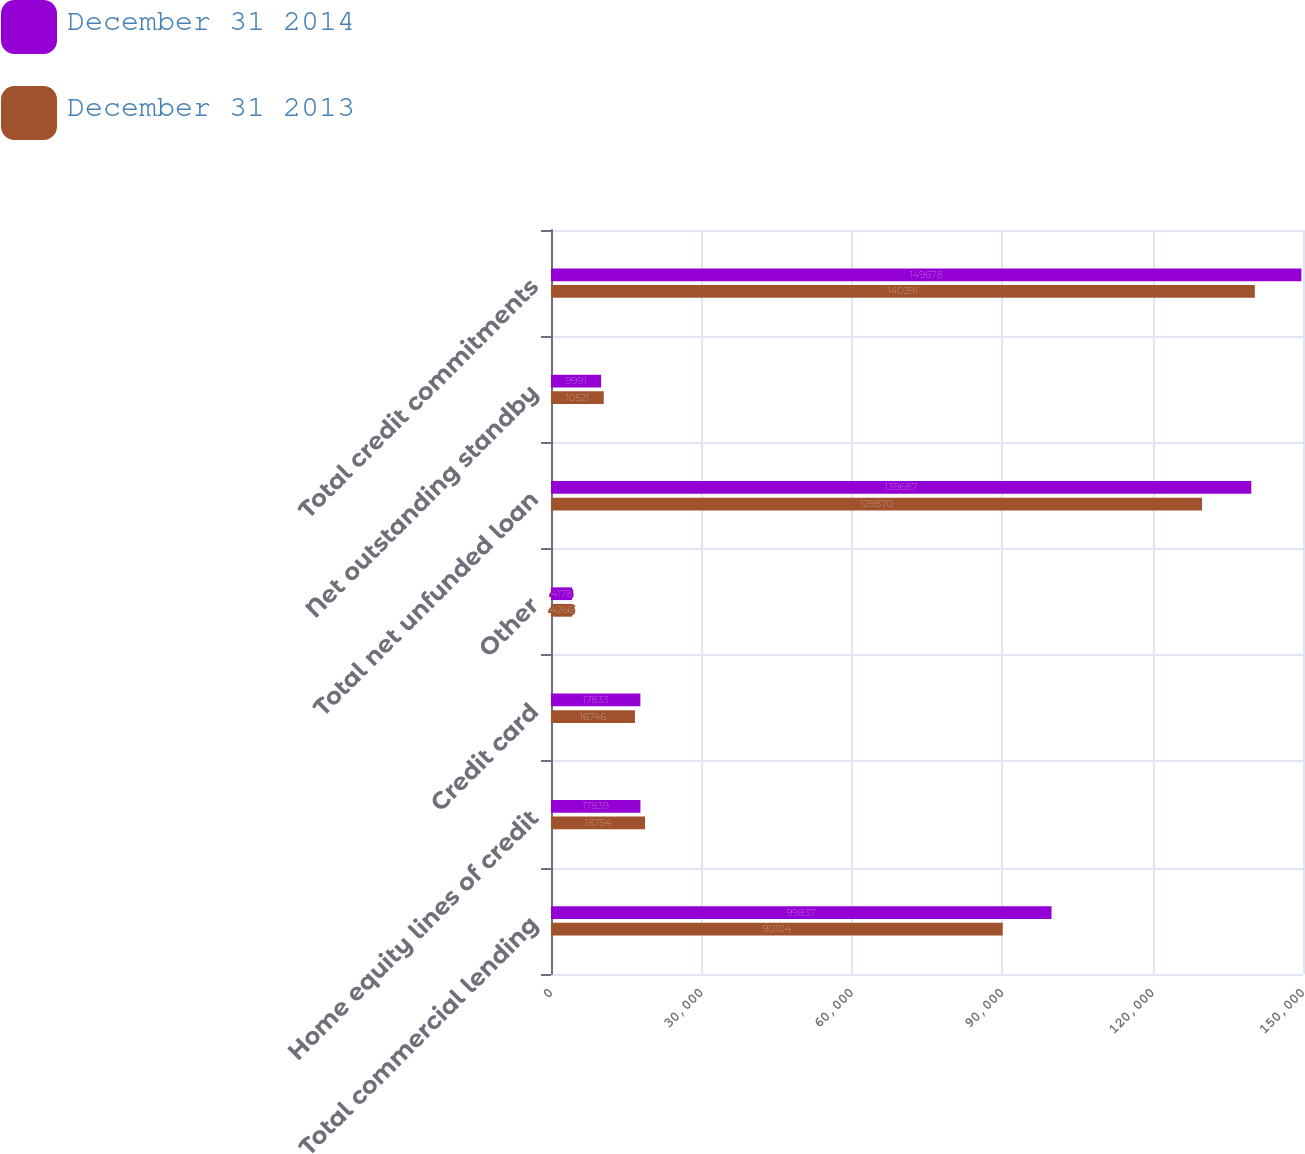Convert chart. <chart><loc_0><loc_0><loc_500><loc_500><stacked_bar_chart><ecel><fcel>Total commercial lending<fcel>Home equity lines of credit<fcel>Credit card<fcel>Other<fcel>Total net unfunded loan<fcel>Net outstanding standby<fcel>Total credit commitments<nl><fcel>December 31 2014<fcel>99837<fcel>17839<fcel>17833<fcel>4178<fcel>139687<fcel>9991<fcel>149678<nl><fcel>December 31 2013<fcel>90104<fcel>18754<fcel>16746<fcel>4266<fcel>129870<fcel>10521<fcel>140391<nl></chart> 